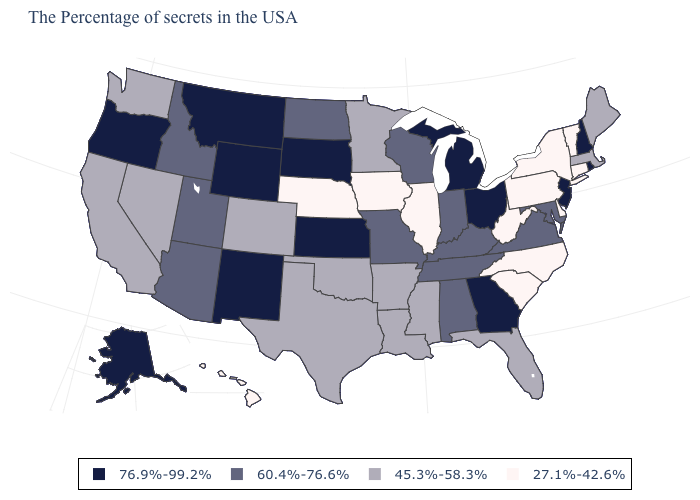Name the states that have a value in the range 60.4%-76.6%?
Concise answer only. Maryland, Virginia, Kentucky, Indiana, Alabama, Tennessee, Wisconsin, Missouri, North Dakota, Utah, Arizona, Idaho. What is the value of South Dakota?
Answer briefly. 76.9%-99.2%. What is the value of Rhode Island?
Give a very brief answer. 76.9%-99.2%. Name the states that have a value in the range 76.9%-99.2%?
Keep it brief. Rhode Island, New Hampshire, New Jersey, Ohio, Georgia, Michigan, Kansas, South Dakota, Wyoming, New Mexico, Montana, Oregon, Alaska. What is the lowest value in states that border Oklahoma?
Short answer required. 45.3%-58.3%. Does New Hampshire have the same value as Alaska?
Keep it brief. Yes. Name the states that have a value in the range 45.3%-58.3%?
Concise answer only. Maine, Massachusetts, Florida, Mississippi, Louisiana, Arkansas, Minnesota, Oklahoma, Texas, Colorado, Nevada, California, Washington. What is the lowest value in the USA?
Short answer required. 27.1%-42.6%. Does Nebraska have the same value as Alaska?
Concise answer only. No. Name the states that have a value in the range 27.1%-42.6%?
Quick response, please. Vermont, Connecticut, New York, Delaware, Pennsylvania, North Carolina, South Carolina, West Virginia, Illinois, Iowa, Nebraska, Hawaii. What is the lowest value in the MidWest?
Keep it brief. 27.1%-42.6%. Does the map have missing data?
Write a very short answer. No. Does North Carolina have the highest value in the USA?
Concise answer only. No. Does the first symbol in the legend represent the smallest category?
Write a very short answer. No. Name the states that have a value in the range 27.1%-42.6%?
Be succinct. Vermont, Connecticut, New York, Delaware, Pennsylvania, North Carolina, South Carolina, West Virginia, Illinois, Iowa, Nebraska, Hawaii. 